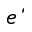<formula> <loc_0><loc_0><loc_500><loc_500>\acute { e }</formula> 